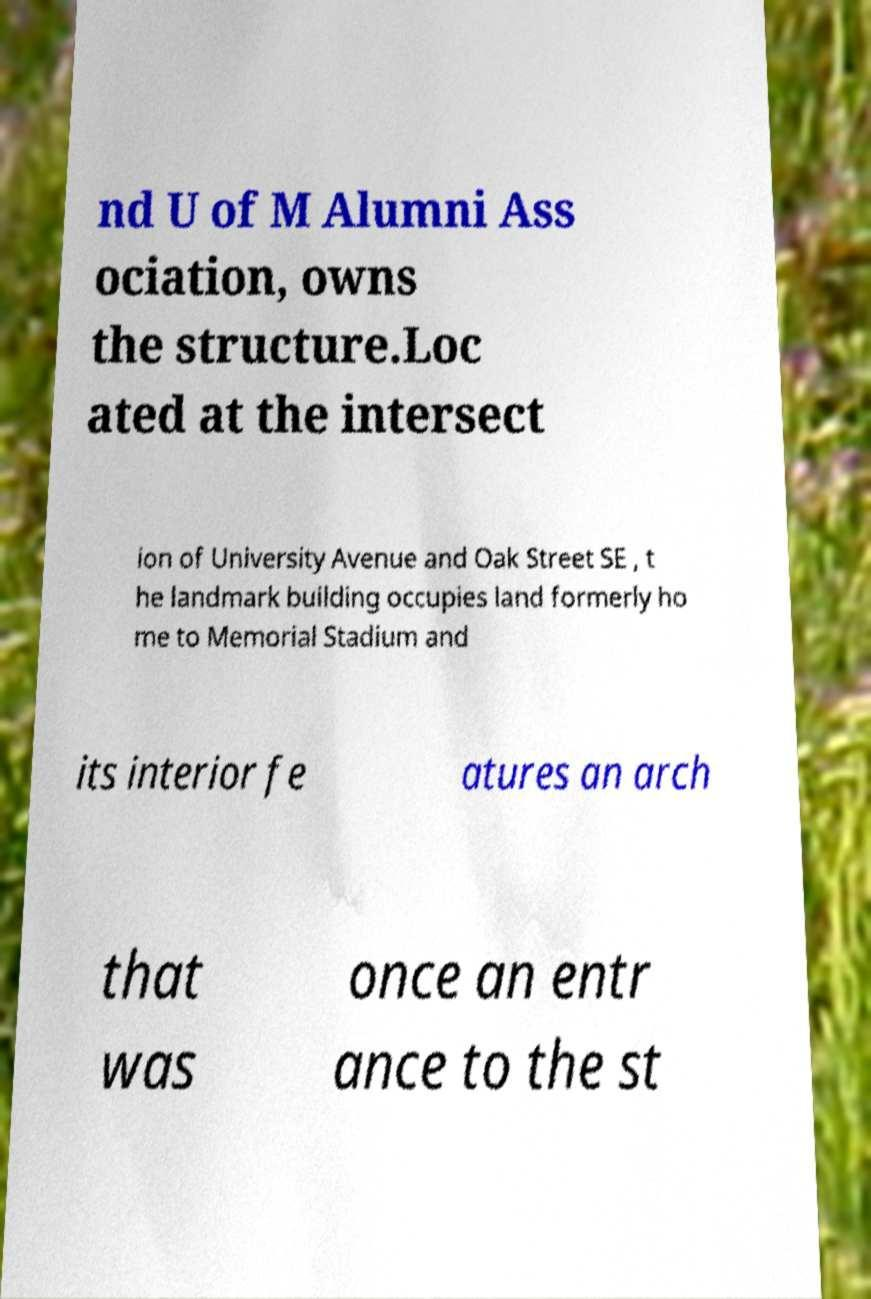Could you assist in decoding the text presented in this image and type it out clearly? nd U of M Alumni Ass ociation, owns the structure.Loc ated at the intersect ion of University Avenue and Oak Street SE , t he landmark building occupies land formerly ho me to Memorial Stadium and its interior fe atures an arch that was once an entr ance to the st 